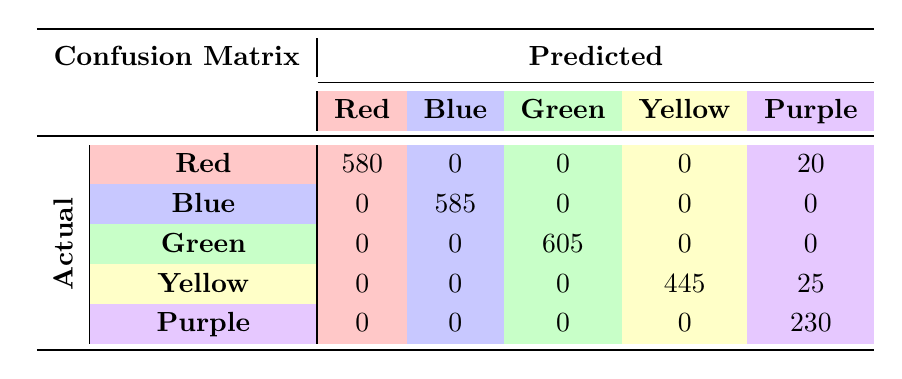What is the total predicted number of buyers for the color Red? To find the total predicted buyers for Red, we look at the "Predicted" row under the "Red" column. The total is 145 (Kenya) + 115 (Nigeria) + 125 (South Africa) + 95 (Ghana) + 100 (Tanzania) = 580.
Answer: 580 How many actual buyers did NOT prefer the color Blue? To find the buyers who did not prefer Blue, we need to sum the buyers for all other colors. The total buyers for non-Blue colors is 150 (Red) + 120 (Green) + 70 (Yellow) + 60 (Purple) + 90 (Ghana) + 110 (Tanzania) = 600.
Answer: 600 Is the predicted value for Yellow buyers in Nigeria higher than actual buyers? The predicted buyers of Yellow in Nigeria is 85 while the actual buyers is 90. Since 85 is less than 90, the statement is false.
Answer: No What is the difference between the actual and predicted buyers for the color Purple in South Africa? The actual buyers for Purple in South Africa is 70, and the predicted buyers is 60. The difference is calculated as 70 - 60 = 10.
Answer: 10 Which color had the highest increase in the number of predicted buyers compared to actual buyers? We will look at each color's predicted and actual values. Red had a decrease of 5 (580 - 580), Blue had an increase of 15 (585 - 570), Green had a decrease of 5 (605 - 600), Yellow had a decrease of 25 (445 - 520), and Purple had a decrease of 70 (230 - 300). The largest increase is 15 for Blue.
Answer: Blue 